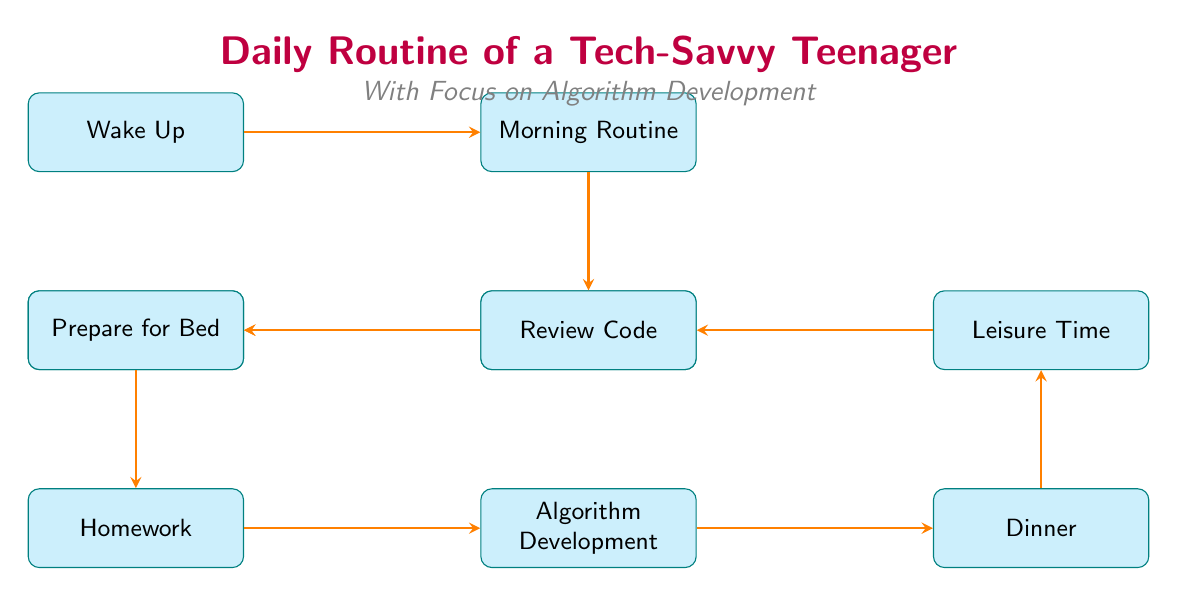What is the first activity in the daily routine? The diagram starts with the node labeled "Wake Up," which indicates it is the first activity in the daily routine.
Answer: Wake Up How many main activities are shown in the diagram? By counting the nodes, there are a total of 8 main activities listed: Wake Up, Morning Routine, School Hours, After School Activities, Homework, Algorithm Development, Dinner, Leisure Time, Review Code, and Prepare for Bed. Thus, there are 10 nodes in total.
Answer: 10 What follows after "Homework"? The flow from "Homework" leads directly to the next node labeled "Algorithm Development," indicating that this is the following activity.
Answer: Algorithm Development What is the activity before "Prepare for Bed"? The node immediately preceding "Prepare for Bed" is labeled "Review Code," indicating that this is the activity that occurs just before preparing for bed.
Answer: Review Code If the teenager completes their homework, which activity do they engage in next? The diagram indicates that after completing "Homework," the next activity is "Algorithm Development," showing the sequential flow from one task to the next.
Answer: Algorithm Development Which activity occurs after "Dinner"? According to the flow of the diagram, "Dinner" is followed by the activity labeled "Leisure Time," displaying the direct progression from one activity to the next.
Answer: Leisure Time What type of diagram is this? The diagram is a flowchart that outlines the daily routine and responsibilities of a tech-savvy teenager, distinguishing the sequences of activities.
Answer: Flowchart What is the overall theme of this diagram? The overall theme described in the title and subtitle of the diagram emphasizes the "Daily Routine of a Tech-Savvy Teenager" focusing specifically on "Algorithm Development."
Answer: Daily Routine of a Tech-Savvy Teenager 